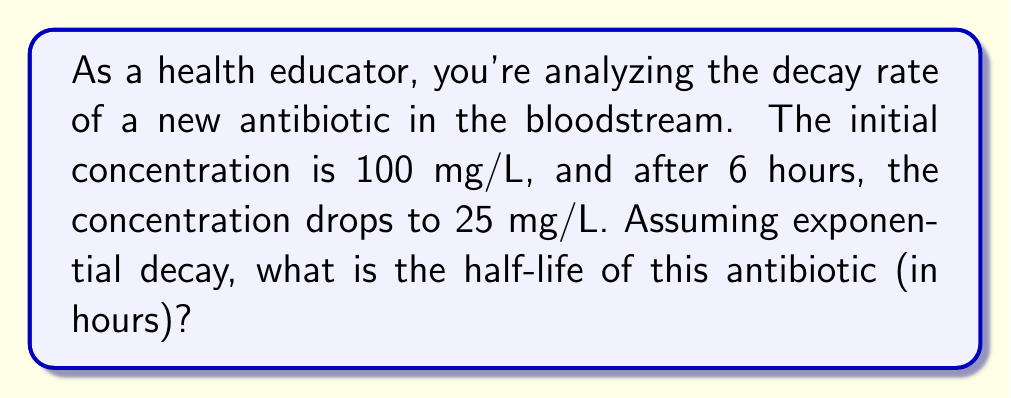Show me your answer to this math problem. Let's approach this step-by-step:

1) The exponential decay function is given by:
   $$C(t) = C_0 e^{-kt}$$
   where $C(t)$ is the concentration at time $t$, $C_0$ is the initial concentration, $k$ is the decay constant, and $t$ is time.

2) We know:
   $C_0 = 100$ mg/L
   $C(6) = 25$ mg/L
   $t = 6$ hours

3) Substituting these values into the equation:
   $$25 = 100 e^{-6k}$$

4) Dividing both sides by 100:
   $$0.25 = e^{-6k}$$

5) Taking the natural log of both sides:
   $$\ln(0.25) = -6k$$

6) Solving for $k$:
   $$k = -\frac{\ln(0.25)}{6} \approx 0.2310$$

7) The half-life $t_{1/2}$ is the time it takes for the concentration to reduce by half. It's related to $k$ by:
   $$t_{1/2} = \frac{\ln(2)}{k}$$

8) Substituting our value for $k$:
   $$t_{1/2} = \frac{\ln(2)}{0.2310} \approx 3.0005$$

Therefore, the half-life of the antibiotic is approximately 3.0005 hours.
Answer: 3.0005 hours 